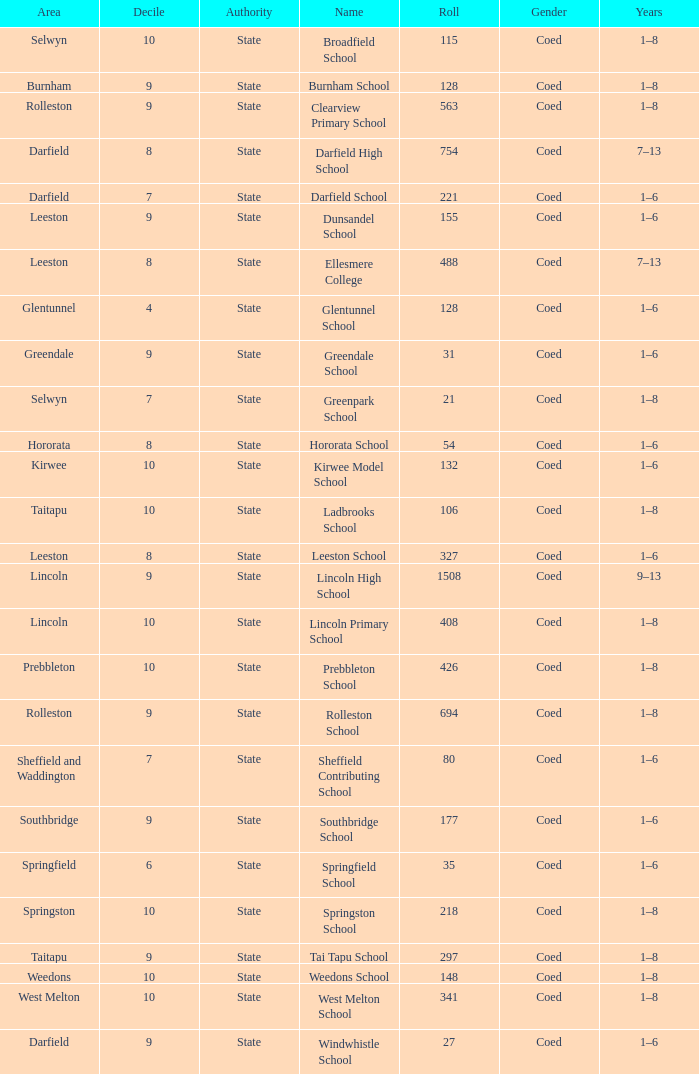Which area has a Decile of 9, and a Roll of 31? Greendale. 